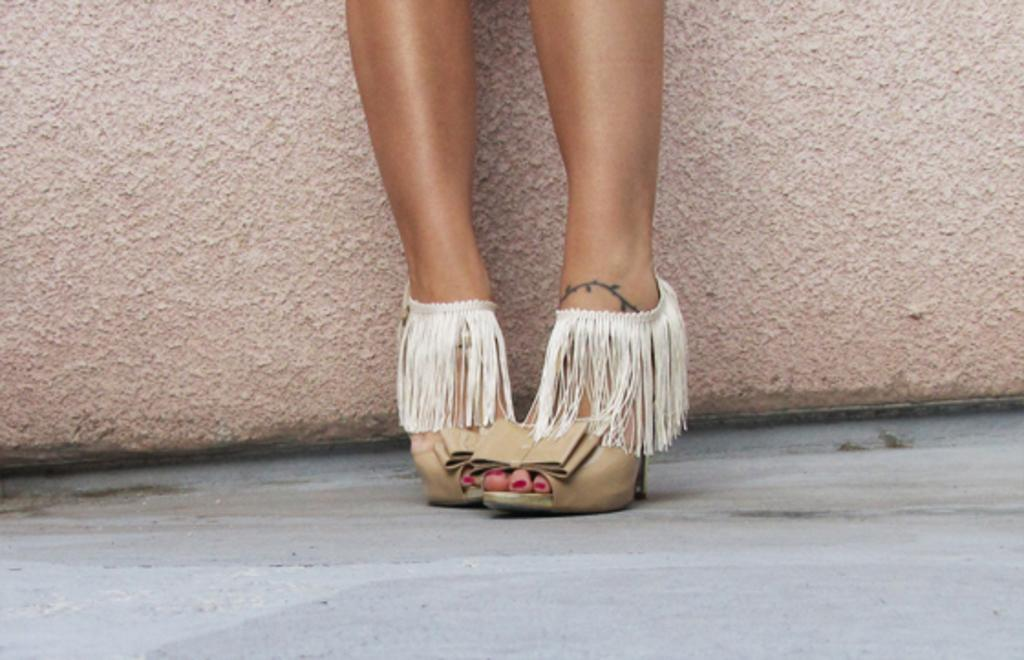What is the main focus of the image? The image shows a close view of a girl's legs. What type of footwear is the girl wearing? The girl is wearing sandals. Can you describe the background of the image? There is a brown texture wall in the background. What is the girl's opinion on the basket in the image? There is no basket present in the image, so it is not possible to determine the girl's opinion on it. 